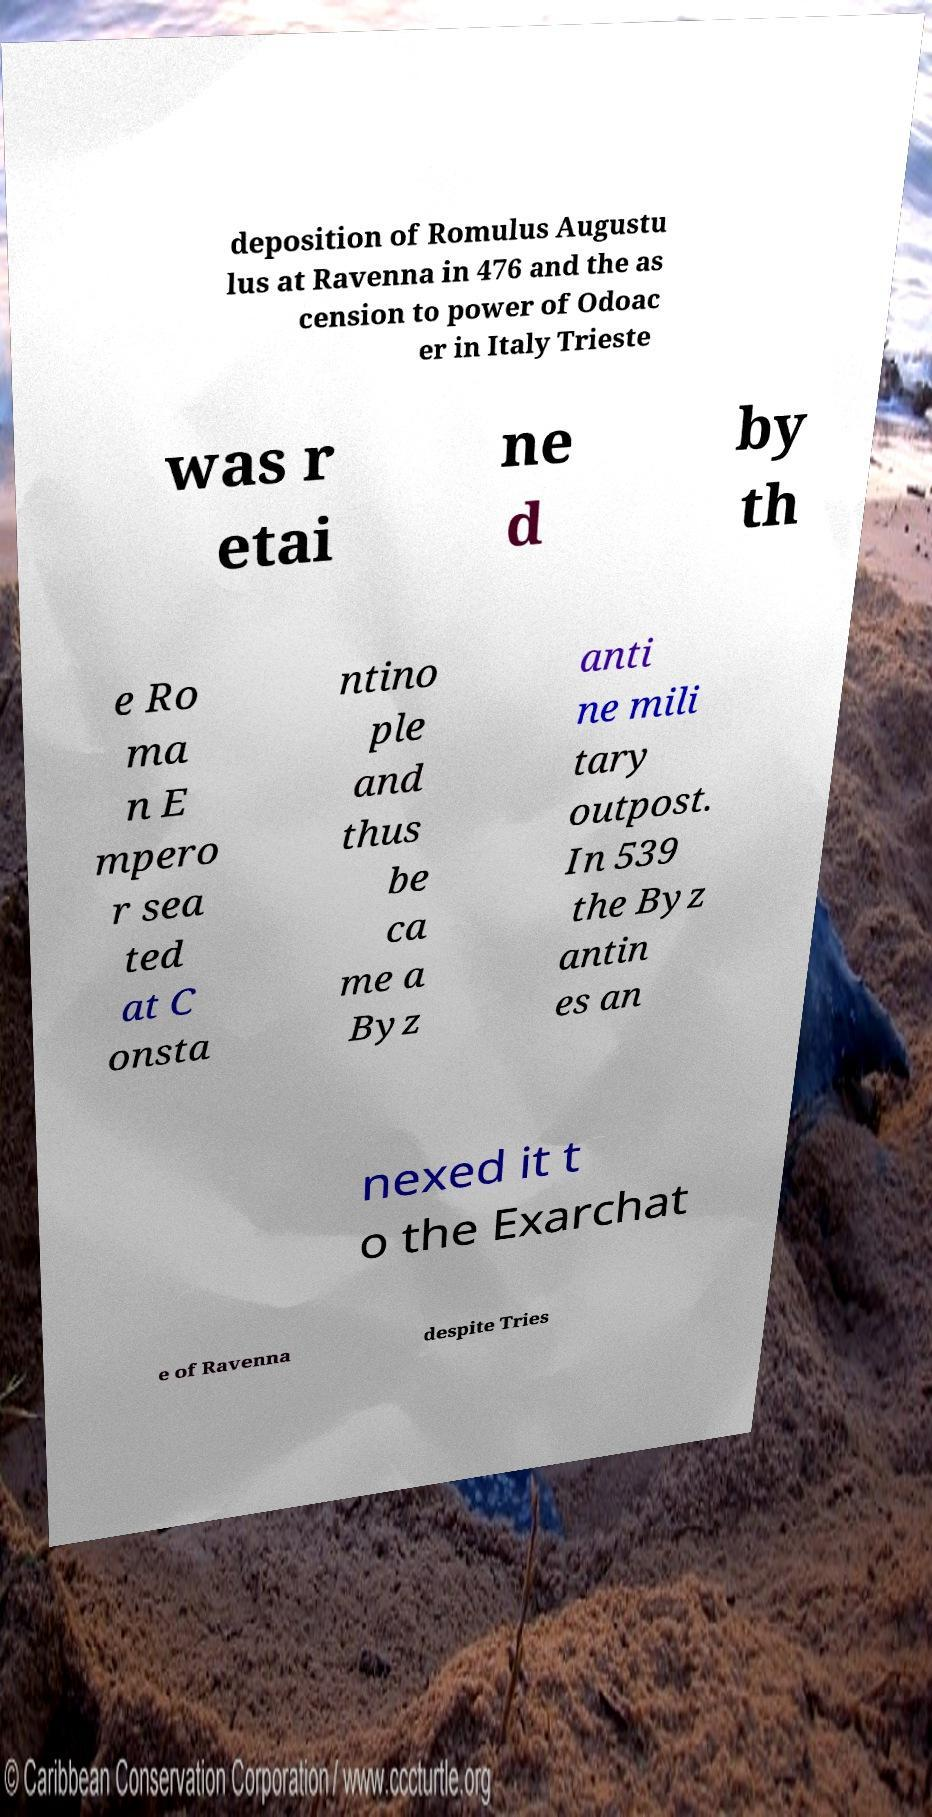Can you read and provide the text displayed in the image?This photo seems to have some interesting text. Can you extract and type it out for me? deposition of Romulus Augustu lus at Ravenna in 476 and the as cension to power of Odoac er in Italy Trieste was r etai ne d by th e Ro ma n E mpero r sea ted at C onsta ntino ple and thus be ca me a Byz anti ne mili tary outpost. In 539 the Byz antin es an nexed it t o the Exarchat e of Ravenna despite Tries 